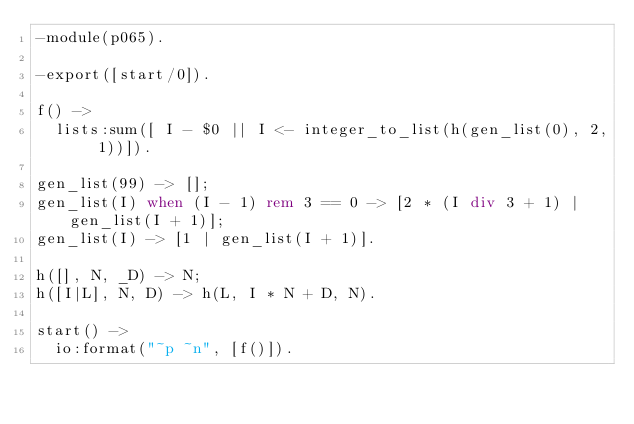<code> <loc_0><loc_0><loc_500><loc_500><_Erlang_>-module(p065).

-export([start/0]).

f() ->
  lists:sum([ I - $0 || I <- integer_to_list(h(gen_list(0), 2, 1))]).

gen_list(99) -> [];
gen_list(I) when (I - 1) rem 3 == 0 -> [2 * (I div 3 + 1) | gen_list(I + 1)];
gen_list(I) -> [1 | gen_list(I + 1)].

h([], N, _D) -> N;
h([I|L], N, D) -> h(L, I * N + D, N).

start() ->
  io:format("~p ~n", [f()]).

</code> 